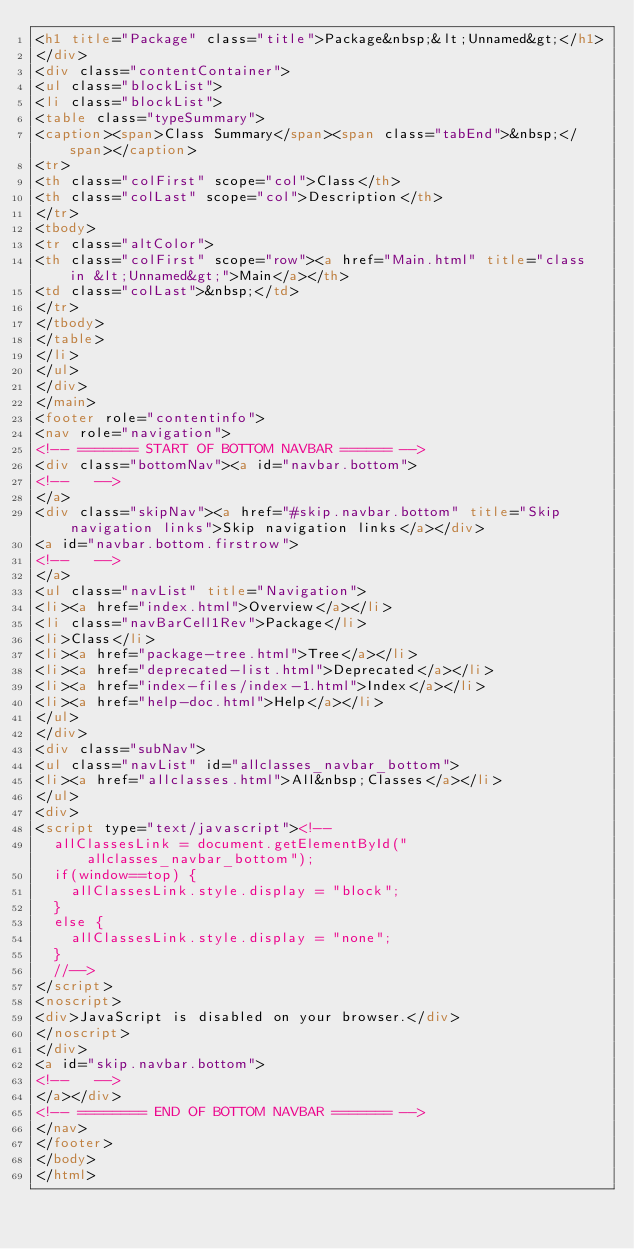Convert code to text. <code><loc_0><loc_0><loc_500><loc_500><_HTML_><h1 title="Package" class="title">Package&nbsp;&lt;Unnamed&gt;</h1>
</div>
<div class="contentContainer">
<ul class="blockList">
<li class="blockList">
<table class="typeSummary">
<caption><span>Class Summary</span><span class="tabEnd">&nbsp;</span></caption>
<tr>
<th class="colFirst" scope="col">Class</th>
<th class="colLast" scope="col">Description</th>
</tr>
<tbody>
<tr class="altColor">
<th class="colFirst" scope="row"><a href="Main.html" title="class in &lt;Unnamed&gt;">Main</a></th>
<td class="colLast">&nbsp;</td>
</tr>
</tbody>
</table>
</li>
</ul>
</div>
</main>
<footer role="contentinfo">
<nav role="navigation">
<!-- ======= START OF BOTTOM NAVBAR ====== -->
<div class="bottomNav"><a id="navbar.bottom">
<!--   -->
</a>
<div class="skipNav"><a href="#skip.navbar.bottom" title="Skip navigation links">Skip navigation links</a></div>
<a id="navbar.bottom.firstrow">
<!--   -->
</a>
<ul class="navList" title="Navigation">
<li><a href="index.html">Overview</a></li>
<li class="navBarCell1Rev">Package</li>
<li>Class</li>
<li><a href="package-tree.html">Tree</a></li>
<li><a href="deprecated-list.html">Deprecated</a></li>
<li><a href="index-files/index-1.html">Index</a></li>
<li><a href="help-doc.html">Help</a></li>
</ul>
</div>
<div class="subNav">
<ul class="navList" id="allclasses_navbar_bottom">
<li><a href="allclasses.html">All&nbsp;Classes</a></li>
</ul>
<div>
<script type="text/javascript"><!--
  allClassesLink = document.getElementById("allclasses_navbar_bottom");
  if(window==top) {
    allClassesLink.style.display = "block";
  }
  else {
    allClassesLink.style.display = "none";
  }
  //-->
</script>
<noscript>
<div>JavaScript is disabled on your browser.</div>
</noscript>
</div>
<a id="skip.navbar.bottom">
<!--   -->
</a></div>
<!-- ======== END OF BOTTOM NAVBAR ======= -->
</nav>
</footer>
</body>
</html>
</code> 